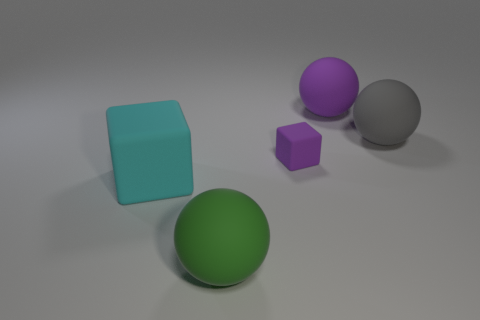The tiny thing has what color?
Your answer should be compact. Purple. There is a large rubber sphere in front of the cyan rubber cube; what number of green matte things are left of it?
Ensure brevity in your answer.  0. There is a rubber thing that is right of the green matte thing and to the left of the large purple thing; how big is it?
Keep it short and to the point. Small. Is there a small gray thing that has the same shape as the small purple thing?
Give a very brief answer. No. How many other purple objects are the same shape as the tiny purple matte object?
Offer a terse response. 0. There is a object in front of the large cyan rubber cube; is its size the same as the rubber object on the left side of the green rubber sphere?
Make the answer very short. Yes. What is the shape of the rubber object that is in front of the rubber block that is on the left side of the purple rubber block?
Your response must be concise. Sphere. Are there an equal number of tiny purple objects that are to the left of the tiny block and tiny gray metal spheres?
Ensure brevity in your answer.  Yes. Are there any purple balls that have the same size as the gray rubber sphere?
Offer a very short reply. Yes. What is the shape of the tiny purple thing?
Your answer should be very brief. Cube. 